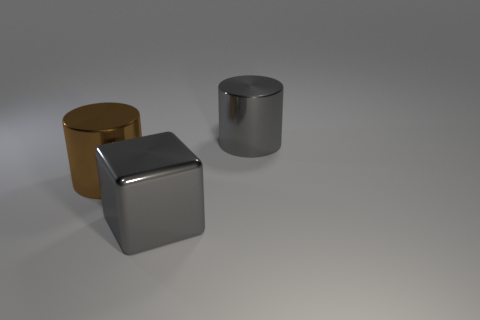Add 1 shiny objects. How many objects exist? 4 Subtract all brown cylinders. How many cylinders are left? 1 Subtract 1 blocks. How many blocks are left? 0 Subtract all cubes. How many objects are left? 2 Add 1 gray shiny things. How many gray shiny things exist? 3 Subtract 0 brown spheres. How many objects are left? 3 Subtract all green cylinders. Subtract all cyan spheres. How many cylinders are left? 2 Subtract all large brown shiny cylinders. Subtract all metal blocks. How many objects are left? 1 Add 2 large blocks. How many large blocks are left? 3 